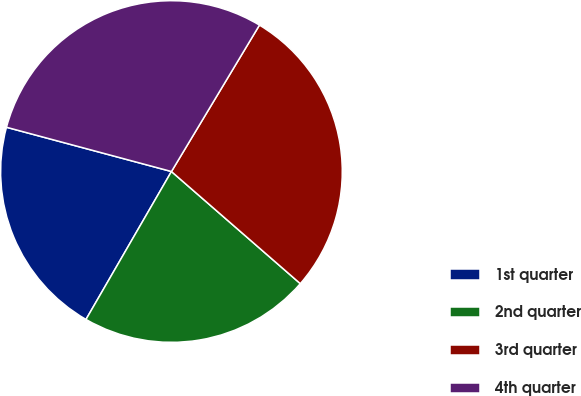<chart> <loc_0><loc_0><loc_500><loc_500><pie_chart><fcel>1st quarter<fcel>2nd quarter<fcel>3rd quarter<fcel>4th quarter<nl><fcel>20.83%<fcel>21.94%<fcel>27.78%<fcel>29.44%<nl></chart> 